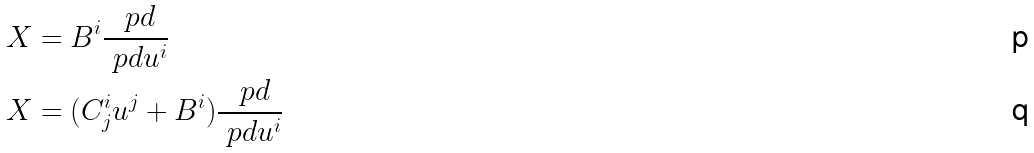Convert formula to latex. <formula><loc_0><loc_0><loc_500><loc_500>X & = B ^ { i } \frac { \ p d } { \ p d u ^ { i } } \\ X & = ( C _ { j } ^ { i } u ^ { j } + B ^ { i } ) \frac { \ p d } { \ p d u ^ { i } }</formula> 